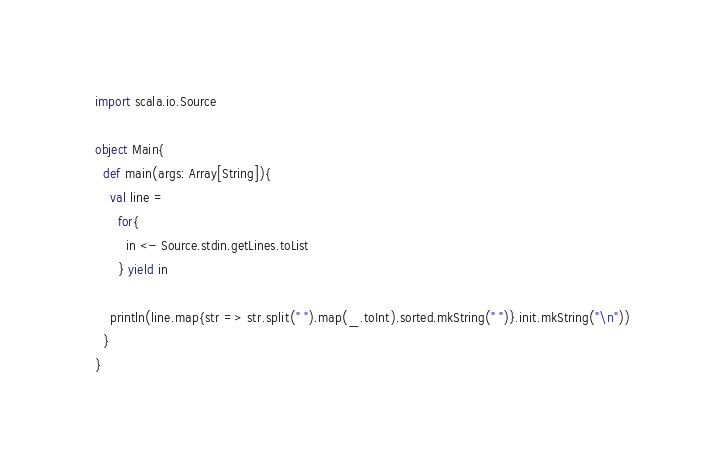Convert code to text. <code><loc_0><loc_0><loc_500><loc_500><_Scala_>import scala.io.Source

object Main{
  def main(args: Array[String]){
    val line =
      for{
        in <- Source.stdin.getLines.toList
      } yield in

    println(line.map{str => str.split(" ").map(_.toInt).sorted.mkString(" ")}.init.mkString("\n"))
  }
}</code> 